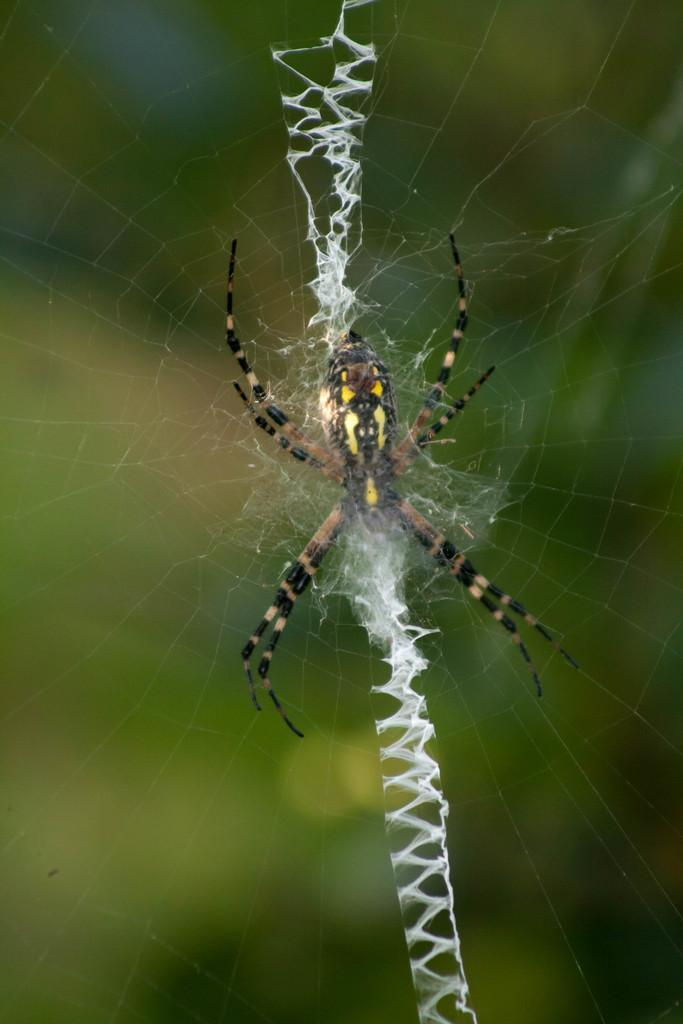What is the main subject of the image? There is a spider in the image. What is associated with the spider in the image? There is a spider web in the image. Can you describe the background of the image? The background of the image is blurry. What type of humor can be seen in the image? There is no humor present in the image; it features a spider and a spider web. Can you tell me how many jars are visible in the image? There are no jars present in the image. 